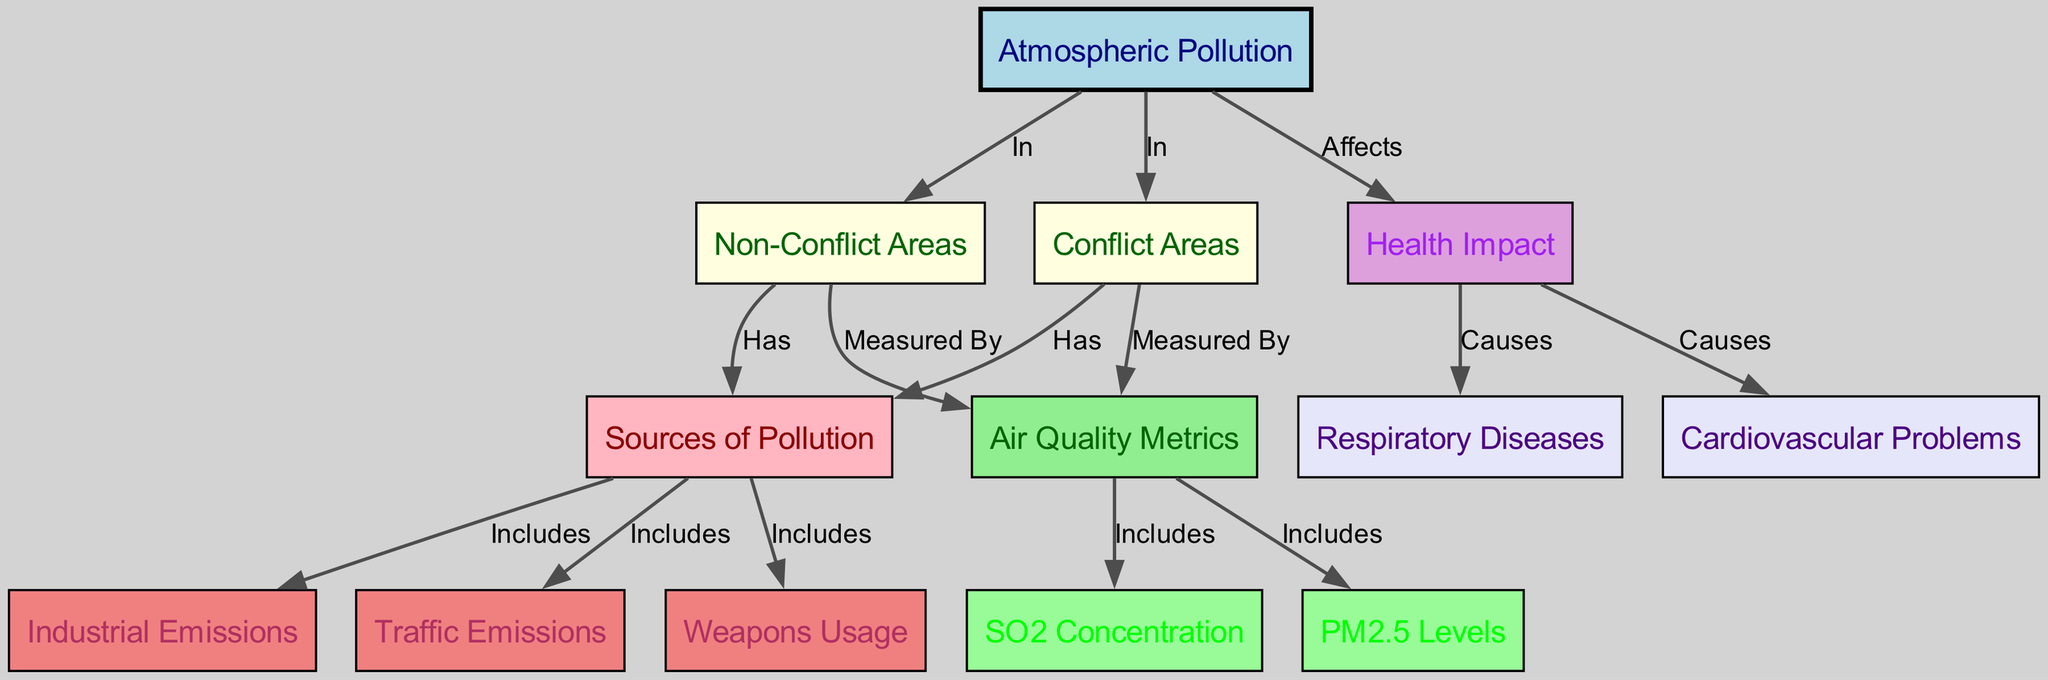What is the main focus of the diagram? The diagram emphasizes "Atmospheric Pollution," which is shown as the central node in the structure, connecting various aspects of pollution in both conflict and non-conflict areas.
Answer: Atmospheric Pollution How many nodes are there in the diagram? The diagram includes 13 nodes in total, which can be counted directly from the list of nodes provided.
Answer: 13 What are the two types of areas compared in the diagram? The diagram clearly identifies "Conflict Areas" and "Non-Conflict Areas" as the two distinct nodes representing the types of areas being analyzed for atmospheric pollution.
Answer: Conflict Areas and Non-Conflict Areas Which sources of pollution are included in conflict areas? The sources of pollution linked to conflict areas include "Industrial Emissions," "Traffic Emissions," and "Weapons Usage," which all branch out from the node labeled "Sources of Pollution."
Answer: Industrial Emissions, Traffic Emissions, Weapons Usage What is affected by atmospheric pollution according to the diagram? The diagram indicates that "Health Impact" is affected by atmospheric pollution, which is directly linked to the central node of atmospheric pollution.
Answer: Health Impact Which air quality metric is included in the diagram? The diagram features "PM2.5 Levels" as one of the specific air quality metrics measured in both conflict and non-conflict areas, indicated by the node under "Air Quality Metrics."
Answer: PM2.5 Levels What specific health problems are caused by atmospheric pollution? According to the diagram, "Respiratory Diseases" and "Cardiovascular Problems" are both consequences of the health impact stemming from atmospheric pollution, as shown in the causal relationships.
Answer: Respiratory Diseases and Cardiovascular Problems How many edges are there linking "Conflict Areas" to "Sources of Pollution"? The diagram has three edges that connect "Conflict Areas" to each of the three sources of pollution, indicating the relationships and connections between them.
Answer: 3 Which type of emissions are specifically measured in the "Non-Conflict Areas"? The emissions measured in "Non-Conflict Areas" as a source of pollution include both "Industrial Emissions" and "Traffic Emissions," as also shown in the connected nodes for air quality metrics.
Answer: Industrial Emissions and Traffic Emissions What is the relationship between "Health Impact" and "Respiratory Diseases"? The diagram illustrates that "Health Impact" causes "Respiratory Diseases," indicating a direct causal relationship between these two aspects within the context of atmospheric pollution.
Answer: Causes 